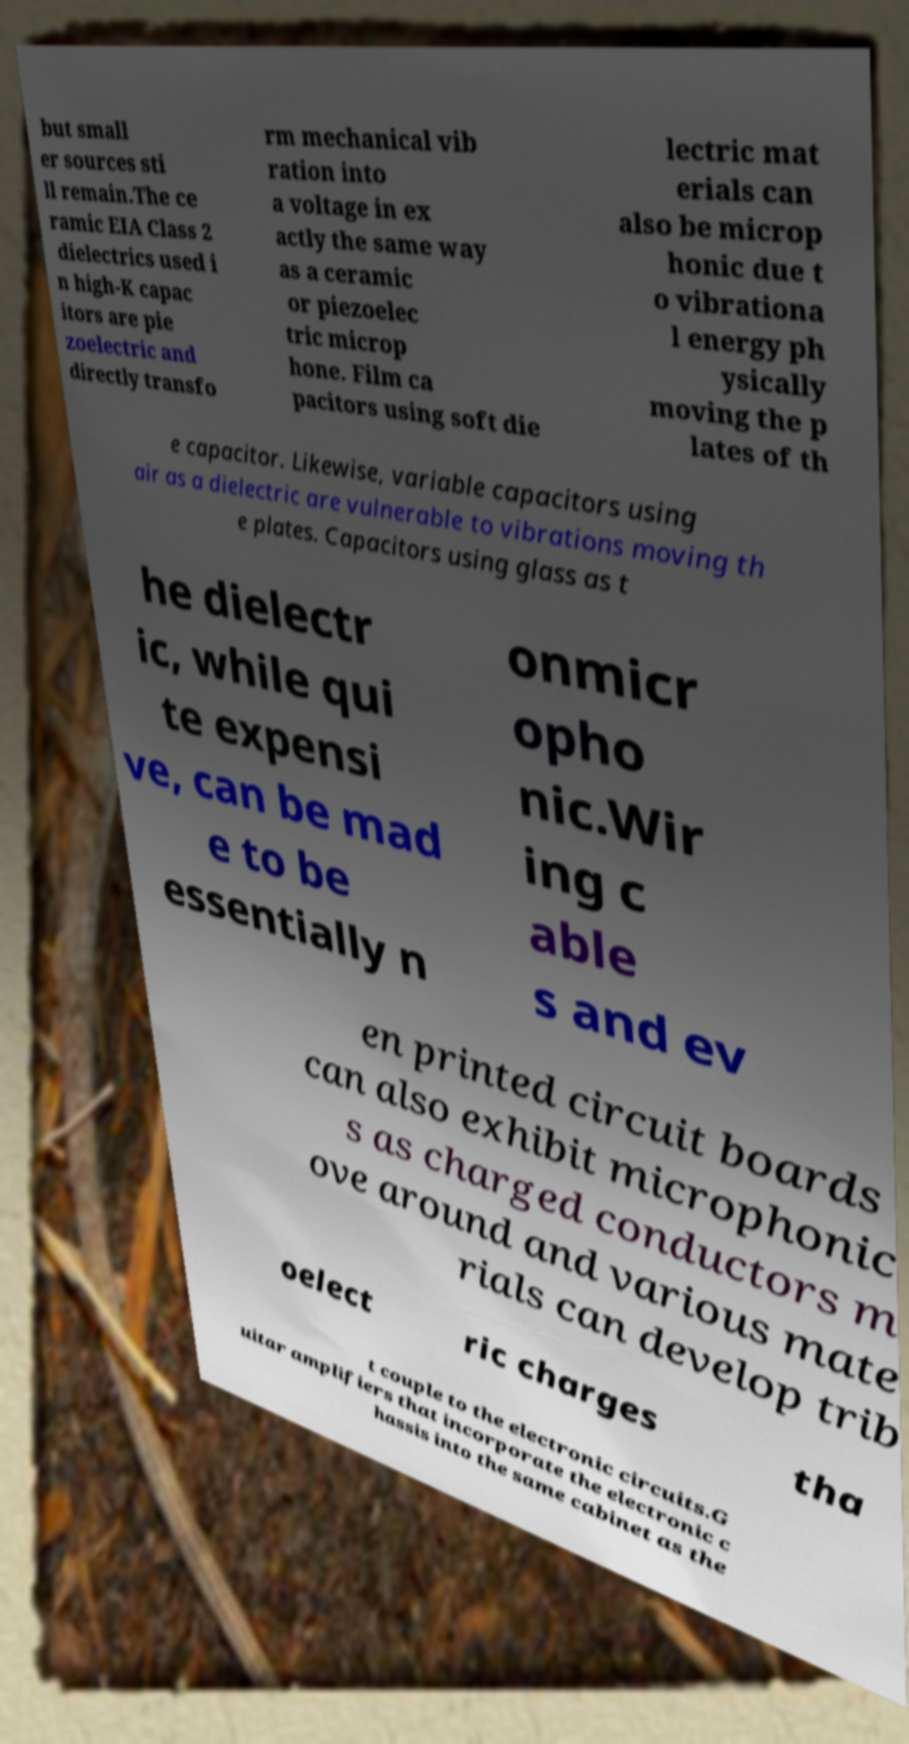What messages or text are displayed in this image? I need them in a readable, typed format. but small er sources sti ll remain.The ce ramic EIA Class 2 dielectrics used i n high-K capac itors are pie zoelectric and directly transfo rm mechanical vib ration into a voltage in ex actly the same way as a ceramic or piezoelec tric microp hone. Film ca pacitors using soft die lectric mat erials can also be microp honic due t o vibrationa l energy ph ysically moving the p lates of th e capacitor. Likewise, variable capacitors using air as a dielectric are vulnerable to vibrations moving th e plates. Capacitors using glass as t he dielectr ic, while qui te expensi ve, can be mad e to be essentially n onmicr opho nic.Wir ing c able s and ev en printed circuit boards can also exhibit microphonic s as charged conductors m ove around and various mate rials can develop trib oelect ric charges tha t couple to the electronic circuits.G uitar amplifiers that incorporate the electronic c hassis into the same cabinet as the 